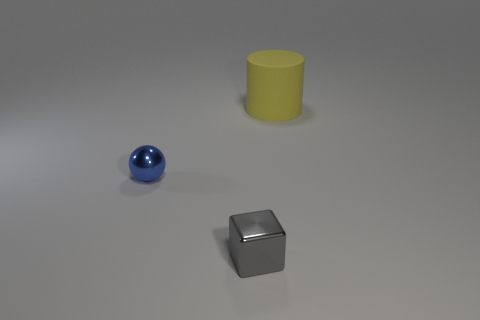Add 2 blue balls. How many objects exist? 5 Subtract 1 cubes. How many cubes are left? 0 Subtract all cyan spheres. Subtract all green cylinders. How many spheres are left? 1 Subtract all green cubes. How many brown spheres are left? 0 Subtract all yellow matte things. Subtract all purple cubes. How many objects are left? 2 Add 2 small shiny things. How many small shiny things are left? 4 Add 3 brown shiny cylinders. How many brown shiny cylinders exist? 3 Subtract 0 green cylinders. How many objects are left? 3 Subtract all cylinders. How many objects are left? 2 